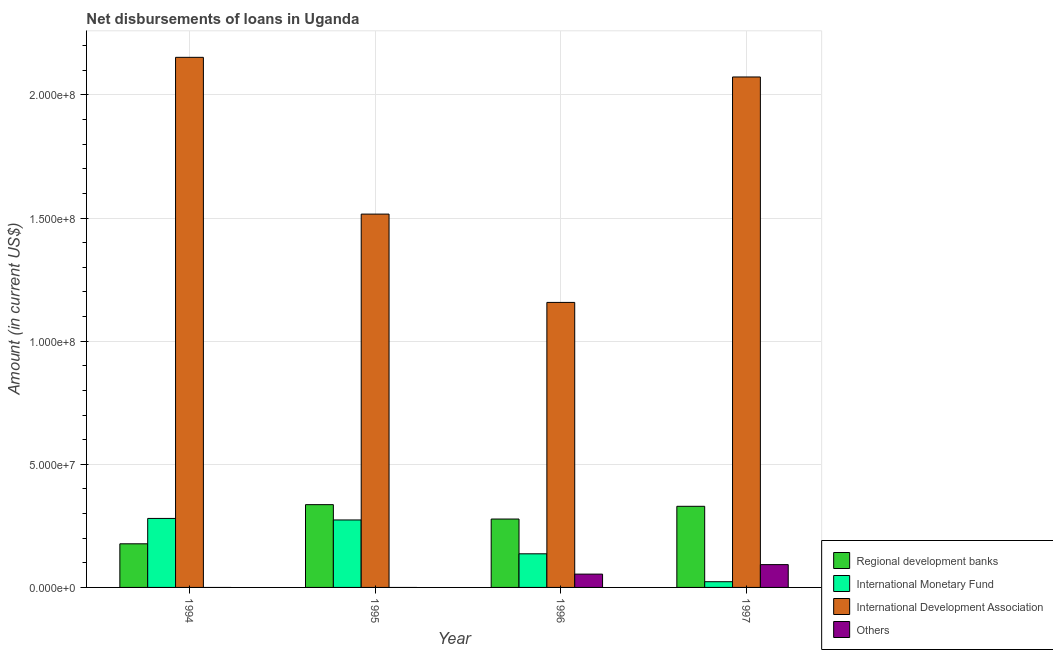Are the number of bars on each tick of the X-axis equal?
Keep it short and to the point. No. How many bars are there on the 3rd tick from the left?
Offer a terse response. 4. In how many cases, is the number of bars for a given year not equal to the number of legend labels?
Make the answer very short. 2. What is the amount of loan disimbursed by international monetary fund in 1995?
Keep it short and to the point. 2.74e+07. Across all years, what is the maximum amount of loan disimbursed by international development association?
Make the answer very short. 2.15e+08. Across all years, what is the minimum amount of loan disimbursed by international development association?
Provide a succinct answer. 1.16e+08. What is the total amount of loan disimbursed by international development association in the graph?
Your answer should be compact. 6.90e+08. What is the difference between the amount of loan disimbursed by international development association in 1994 and that in 1997?
Provide a succinct answer. 7.98e+06. What is the difference between the amount of loan disimbursed by other organisations in 1995 and the amount of loan disimbursed by international monetary fund in 1997?
Your answer should be very brief. -9.26e+06. What is the average amount of loan disimbursed by regional development banks per year?
Provide a succinct answer. 2.80e+07. In the year 1994, what is the difference between the amount of loan disimbursed by international development association and amount of loan disimbursed by other organisations?
Provide a short and direct response. 0. What is the ratio of the amount of loan disimbursed by international monetary fund in 1996 to that in 1997?
Make the answer very short. 5.88. Is the difference between the amount of loan disimbursed by international development association in 1996 and 1997 greater than the difference between the amount of loan disimbursed by international monetary fund in 1996 and 1997?
Give a very brief answer. No. What is the difference between the highest and the second highest amount of loan disimbursed by regional development banks?
Offer a terse response. 6.69e+05. What is the difference between the highest and the lowest amount of loan disimbursed by international monetary fund?
Offer a very short reply. 2.57e+07. In how many years, is the amount of loan disimbursed by regional development banks greater than the average amount of loan disimbursed by regional development banks taken over all years?
Keep it short and to the point. 2. Is the sum of the amount of loan disimbursed by regional development banks in 1995 and 1996 greater than the maximum amount of loan disimbursed by international monetary fund across all years?
Provide a short and direct response. Yes. How many years are there in the graph?
Give a very brief answer. 4. Are the values on the major ticks of Y-axis written in scientific E-notation?
Your response must be concise. Yes. How many legend labels are there?
Ensure brevity in your answer.  4. How are the legend labels stacked?
Provide a succinct answer. Vertical. What is the title of the graph?
Offer a very short reply. Net disbursements of loans in Uganda. What is the label or title of the X-axis?
Provide a short and direct response. Year. What is the Amount (in current US$) in Regional development banks in 1994?
Provide a short and direct response. 1.77e+07. What is the Amount (in current US$) of International Monetary Fund in 1994?
Provide a short and direct response. 2.80e+07. What is the Amount (in current US$) in International Development Association in 1994?
Keep it short and to the point. 2.15e+08. What is the Amount (in current US$) in Others in 1994?
Your answer should be compact. 0. What is the Amount (in current US$) in Regional development banks in 1995?
Give a very brief answer. 3.36e+07. What is the Amount (in current US$) of International Monetary Fund in 1995?
Offer a very short reply. 2.74e+07. What is the Amount (in current US$) in International Development Association in 1995?
Provide a short and direct response. 1.52e+08. What is the Amount (in current US$) of Regional development banks in 1996?
Your answer should be very brief. 2.78e+07. What is the Amount (in current US$) of International Monetary Fund in 1996?
Provide a short and direct response. 1.37e+07. What is the Amount (in current US$) of International Development Association in 1996?
Provide a succinct answer. 1.16e+08. What is the Amount (in current US$) of Others in 1996?
Offer a terse response. 5.41e+06. What is the Amount (in current US$) of Regional development banks in 1997?
Your answer should be compact. 3.29e+07. What is the Amount (in current US$) in International Monetary Fund in 1997?
Offer a very short reply. 2.32e+06. What is the Amount (in current US$) in International Development Association in 1997?
Your response must be concise. 2.07e+08. What is the Amount (in current US$) in Others in 1997?
Provide a short and direct response. 9.26e+06. Across all years, what is the maximum Amount (in current US$) in Regional development banks?
Your answer should be compact. 3.36e+07. Across all years, what is the maximum Amount (in current US$) in International Monetary Fund?
Your response must be concise. 2.80e+07. Across all years, what is the maximum Amount (in current US$) of International Development Association?
Your answer should be compact. 2.15e+08. Across all years, what is the maximum Amount (in current US$) of Others?
Keep it short and to the point. 9.26e+06. Across all years, what is the minimum Amount (in current US$) of Regional development banks?
Provide a succinct answer. 1.77e+07. Across all years, what is the minimum Amount (in current US$) in International Monetary Fund?
Keep it short and to the point. 2.32e+06. Across all years, what is the minimum Amount (in current US$) of International Development Association?
Provide a succinct answer. 1.16e+08. Across all years, what is the minimum Amount (in current US$) in Others?
Give a very brief answer. 0. What is the total Amount (in current US$) in Regional development banks in the graph?
Keep it short and to the point. 1.12e+08. What is the total Amount (in current US$) of International Monetary Fund in the graph?
Offer a terse response. 7.14e+07. What is the total Amount (in current US$) in International Development Association in the graph?
Your response must be concise. 6.90e+08. What is the total Amount (in current US$) in Others in the graph?
Give a very brief answer. 1.47e+07. What is the difference between the Amount (in current US$) in Regional development banks in 1994 and that in 1995?
Your response must be concise. -1.59e+07. What is the difference between the Amount (in current US$) of International Monetary Fund in 1994 and that in 1995?
Provide a succinct answer. 6.24e+05. What is the difference between the Amount (in current US$) in International Development Association in 1994 and that in 1995?
Provide a short and direct response. 6.37e+07. What is the difference between the Amount (in current US$) in Regional development banks in 1994 and that in 1996?
Your answer should be very brief. -1.01e+07. What is the difference between the Amount (in current US$) of International Monetary Fund in 1994 and that in 1996?
Provide a succinct answer. 1.44e+07. What is the difference between the Amount (in current US$) in International Development Association in 1994 and that in 1996?
Provide a short and direct response. 9.95e+07. What is the difference between the Amount (in current US$) of Regional development banks in 1994 and that in 1997?
Your response must be concise. -1.52e+07. What is the difference between the Amount (in current US$) in International Monetary Fund in 1994 and that in 1997?
Your response must be concise. 2.57e+07. What is the difference between the Amount (in current US$) of International Development Association in 1994 and that in 1997?
Your response must be concise. 7.98e+06. What is the difference between the Amount (in current US$) in Regional development banks in 1995 and that in 1996?
Offer a terse response. 5.84e+06. What is the difference between the Amount (in current US$) in International Monetary Fund in 1995 and that in 1996?
Offer a terse response. 1.37e+07. What is the difference between the Amount (in current US$) of International Development Association in 1995 and that in 1996?
Make the answer very short. 3.59e+07. What is the difference between the Amount (in current US$) of Regional development banks in 1995 and that in 1997?
Your answer should be compact. 6.69e+05. What is the difference between the Amount (in current US$) of International Monetary Fund in 1995 and that in 1997?
Your response must be concise. 2.51e+07. What is the difference between the Amount (in current US$) in International Development Association in 1995 and that in 1997?
Your answer should be compact. -5.57e+07. What is the difference between the Amount (in current US$) in Regional development banks in 1996 and that in 1997?
Keep it short and to the point. -5.17e+06. What is the difference between the Amount (in current US$) in International Monetary Fund in 1996 and that in 1997?
Provide a succinct answer. 1.13e+07. What is the difference between the Amount (in current US$) in International Development Association in 1996 and that in 1997?
Your answer should be compact. -9.16e+07. What is the difference between the Amount (in current US$) of Others in 1996 and that in 1997?
Your answer should be very brief. -3.86e+06. What is the difference between the Amount (in current US$) of Regional development banks in 1994 and the Amount (in current US$) of International Monetary Fund in 1995?
Your answer should be compact. -9.68e+06. What is the difference between the Amount (in current US$) of Regional development banks in 1994 and the Amount (in current US$) of International Development Association in 1995?
Offer a very short reply. -1.34e+08. What is the difference between the Amount (in current US$) in International Monetary Fund in 1994 and the Amount (in current US$) in International Development Association in 1995?
Provide a succinct answer. -1.24e+08. What is the difference between the Amount (in current US$) of Regional development banks in 1994 and the Amount (in current US$) of International Monetary Fund in 1996?
Keep it short and to the point. 4.06e+06. What is the difference between the Amount (in current US$) of Regional development banks in 1994 and the Amount (in current US$) of International Development Association in 1996?
Offer a terse response. -9.80e+07. What is the difference between the Amount (in current US$) of Regional development banks in 1994 and the Amount (in current US$) of Others in 1996?
Keep it short and to the point. 1.23e+07. What is the difference between the Amount (in current US$) of International Monetary Fund in 1994 and the Amount (in current US$) of International Development Association in 1996?
Your response must be concise. -8.77e+07. What is the difference between the Amount (in current US$) of International Monetary Fund in 1994 and the Amount (in current US$) of Others in 1996?
Keep it short and to the point. 2.26e+07. What is the difference between the Amount (in current US$) of International Development Association in 1994 and the Amount (in current US$) of Others in 1996?
Give a very brief answer. 2.10e+08. What is the difference between the Amount (in current US$) of Regional development banks in 1994 and the Amount (in current US$) of International Monetary Fund in 1997?
Ensure brevity in your answer.  1.54e+07. What is the difference between the Amount (in current US$) in Regional development banks in 1994 and the Amount (in current US$) in International Development Association in 1997?
Make the answer very short. -1.90e+08. What is the difference between the Amount (in current US$) of Regional development banks in 1994 and the Amount (in current US$) of Others in 1997?
Keep it short and to the point. 8.45e+06. What is the difference between the Amount (in current US$) in International Monetary Fund in 1994 and the Amount (in current US$) in International Development Association in 1997?
Give a very brief answer. -1.79e+08. What is the difference between the Amount (in current US$) of International Monetary Fund in 1994 and the Amount (in current US$) of Others in 1997?
Make the answer very short. 1.88e+07. What is the difference between the Amount (in current US$) of International Development Association in 1994 and the Amount (in current US$) of Others in 1997?
Make the answer very short. 2.06e+08. What is the difference between the Amount (in current US$) of Regional development banks in 1995 and the Amount (in current US$) of International Monetary Fund in 1996?
Ensure brevity in your answer.  2.00e+07. What is the difference between the Amount (in current US$) in Regional development banks in 1995 and the Amount (in current US$) in International Development Association in 1996?
Your answer should be very brief. -8.21e+07. What is the difference between the Amount (in current US$) in Regional development banks in 1995 and the Amount (in current US$) in Others in 1996?
Offer a very short reply. 2.82e+07. What is the difference between the Amount (in current US$) of International Monetary Fund in 1995 and the Amount (in current US$) of International Development Association in 1996?
Provide a short and direct response. -8.83e+07. What is the difference between the Amount (in current US$) in International Monetary Fund in 1995 and the Amount (in current US$) in Others in 1996?
Your answer should be compact. 2.20e+07. What is the difference between the Amount (in current US$) of International Development Association in 1995 and the Amount (in current US$) of Others in 1996?
Provide a short and direct response. 1.46e+08. What is the difference between the Amount (in current US$) of Regional development banks in 1995 and the Amount (in current US$) of International Monetary Fund in 1997?
Offer a very short reply. 3.13e+07. What is the difference between the Amount (in current US$) in Regional development banks in 1995 and the Amount (in current US$) in International Development Association in 1997?
Give a very brief answer. -1.74e+08. What is the difference between the Amount (in current US$) in Regional development banks in 1995 and the Amount (in current US$) in Others in 1997?
Offer a very short reply. 2.44e+07. What is the difference between the Amount (in current US$) in International Monetary Fund in 1995 and the Amount (in current US$) in International Development Association in 1997?
Offer a very short reply. -1.80e+08. What is the difference between the Amount (in current US$) of International Monetary Fund in 1995 and the Amount (in current US$) of Others in 1997?
Your response must be concise. 1.81e+07. What is the difference between the Amount (in current US$) of International Development Association in 1995 and the Amount (in current US$) of Others in 1997?
Your answer should be compact. 1.42e+08. What is the difference between the Amount (in current US$) in Regional development banks in 1996 and the Amount (in current US$) in International Monetary Fund in 1997?
Offer a terse response. 2.55e+07. What is the difference between the Amount (in current US$) in Regional development banks in 1996 and the Amount (in current US$) in International Development Association in 1997?
Offer a very short reply. -1.80e+08. What is the difference between the Amount (in current US$) of Regional development banks in 1996 and the Amount (in current US$) of Others in 1997?
Provide a short and direct response. 1.85e+07. What is the difference between the Amount (in current US$) in International Monetary Fund in 1996 and the Amount (in current US$) in International Development Association in 1997?
Make the answer very short. -1.94e+08. What is the difference between the Amount (in current US$) in International Monetary Fund in 1996 and the Amount (in current US$) in Others in 1997?
Provide a succinct answer. 4.39e+06. What is the difference between the Amount (in current US$) of International Development Association in 1996 and the Amount (in current US$) of Others in 1997?
Your response must be concise. 1.06e+08. What is the average Amount (in current US$) of Regional development banks per year?
Give a very brief answer. 2.80e+07. What is the average Amount (in current US$) in International Monetary Fund per year?
Provide a succinct answer. 1.78e+07. What is the average Amount (in current US$) of International Development Association per year?
Keep it short and to the point. 1.72e+08. What is the average Amount (in current US$) of Others per year?
Provide a succinct answer. 3.67e+06. In the year 1994, what is the difference between the Amount (in current US$) in Regional development banks and Amount (in current US$) in International Monetary Fund?
Keep it short and to the point. -1.03e+07. In the year 1994, what is the difference between the Amount (in current US$) in Regional development banks and Amount (in current US$) in International Development Association?
Your answer should be very brief. -1.98e+08. In the year 1994, what is the difference between the Amount (in current US$) in International Monetary Fund and Amount (in current US$) in International Development Association?
Provide a short and direct response. -1.87e+08. In the year 1995, what is the difference between the Amount (in current US$) of Regional development banks and Amount (in current US$) of International Monetary Fund?
Keep it short and to the point. 6.22e+06. In the year 1995, what is the difference between the Amount (in current US$) of Regional development banks and Amount (in current US$) of International Development Association?
Keep it short and to the point. -1.18e+08. In the year 1995, what is the difference between the Amount (in current US$) in International Monetary Fund and Amount (in current US$) in International Development Association?
Your answer should be very brief. -1.24e+08. In the year 1996, what is the difference between the Amount (in current US$) in Regional development banks and Amount (in current US$) in International Monetary Fund?
Offer a very short reply. 1.41e+07. In the year 1996, what is the difference between the Amount (in current US$) in Regional development banks and Amount (in current US$) in International Development Association?
Give a very brief answer. -8.80e+07. In the year 1996, what is the difference between the Amount (in current US$) of Regional development banks and Amount (in current US$) of Others?
Give a very brief answer. 2.24e+07. In the year 1996, what is the difference between the Amount (in current US$) in International Monetary Fund and Amount (in current US$) in International Development Association?
Provide a succinct answer. -1.02e+08. In the year 1996, what is the difference between the Amount (in current US$) of International Monetary Fund and Amount (in current US$) of Others?
Give a very brief answer. 8.24e+06. In the year 1996, what is the difference between the Amount (in current US$) of International Development Association and Amount (in current US$) of Others?
Give a very brief answer. 1.10e+08. In the year 1997, what is the difference between the Amount (in current US$) of Regional development banks and Amount (in current US$) of International Monetary Fund?
Provide a succinct answer. 3.06e+07. In the year 1997, what is the difference between the Amount (in current US$) in Regional development banks and Amount (in current US$) in International Development Association?
Keep it short and to the point. -1.74e+08. In the year 1997, what is the difference between the Amount (in current US$) of Regional development banks and Amount (in current US$) of Others?
Offer a terse response. 2.37e+07. In the year 1997, what is the difference between the Amount (in current US$) of International Monetary Fund and Amount (in current US$) of International Development Association?
Keep it short and to the point. -2.05e+08. In the year 1997, what is the difference between the Amount (in current US$) of International Monetary Fund and Amount (in current US$) of Others?
Your answer should be very brief. -6.94e+06. In the year 1997, what is the difference between the Amount (in current US$) in International Development Association and Amount (in current US$) in Others?
Your response must be concise. 1.98e+08. What is the ratio of the Amount (in current US$) in Regional development banks in 1994 to that in 1995?
Make the answer very short. 0.53. What is the ratio of the Amount (in current US$) in International Monetary Fund in 1994 to that in 1995?
Make the answer very short. 1.02. What is the ratio of the Amount (in current US$) of International Development Association in 1994 to that in 1995?
Offer a terse response. 1.42. What is the ratio of the Amount (in current US$) of Regional development banks in 1994 to that in 1996?
Keep it short and to the point. 0.64. What is the ratio of the Amount (in current US$) in International Monetary Fund in 1994 to that in 1996?
Your answer should be very brief. 2.05. What is the ratio of the Amount (in current US$) in International Development Association in 1994 to that in 1996?
Your answer should be very brief. 1.86. What is the ratio of the Amount (in current US$) of Regional development banks in 1994 to that in 1997?
Provide a succinct answer. 0.54. What is the ratio of the Amount (in current US$) in International Monetary Fund in 1994 to that in 1997?
Make the answer very short. 12.08. What is the ratio of the Amount (in current US$) of International Development Association in 1994 to that in 1997?
Your response must be concise. 1.04. What is the ratio of the Amount (in current US$) of Regional development banks in 1995 to that in 1996?
Your answer should be very brief. 1.21. What is the ratio of the Amount (in current US$) of International Monetary Fund in 1995 to that in 1996?
Provide a short and direct response. 2.01. What is the ratio of the Amount (in current US$) of International Development Association in 1995 to that in 1996?
Give a very brief answer. 1.31. What is the ratio of the Amount (in current US$) in Regional development banks in 1995 to that in 1997?
Offer a terse response. 1.02. What is the ratio of the Amount (in current US$) in International Monetary Fund in 1995 to that in 1997?
Offer a very short reply. 11.81. What is the ratio of the Amount (in current US$) of International Development Association in 1995 to that in 1997?
Provide a short and direct response. 0.73. What is the ratio of the Amount (in current US$) in Regional development banks in 1996 to that in 1997?
Provide a short and direct response. 0.84. What is the ratio of the Amount (in current US$) of International Monetary Fund in 1996 to that in 1997?
Provide a short and direct response. 5.88. What is the ratio of the Amount (in current US$) in International Development Association in 1996 to that in 1997?
Give a very brief answer. 0.56. What is the ratio of the Amount (in current US$) in Others in 1996 to that in 1997?
Your answer should be very brief. 0.58. What is the difference between the highest and the second highest Amount (in current US$) in Regional development banks?
Your response must be concise. 6.69e+05. What is the difference between the highest and the second highest Amount (in current US$) in International Monetary Fund?
Your response must be concise. 6.24e+05. What is the difference between the highest and the second highest Amount (in current US$) in International Development Association?
Offer a very short reply. 7.98e+06. What is the difference between the highest and the lowest Amount (in current US$) in Regional development banks?
Your answer should be very brief. 1.59e+07. What is the difference between the highest and the lowest Amount (in current US$) in International Monetary Fund?
Your answer should be compact. 2.57e+07. What is the difference between the highest and the lowest Amount (in current US$) of International Development Association?
Offer a very short reply. 9.95e+07. What is the difference between the highest and the lowest Amount (in current US$) in Others?
Offer a terse response. 9.26e+06. 